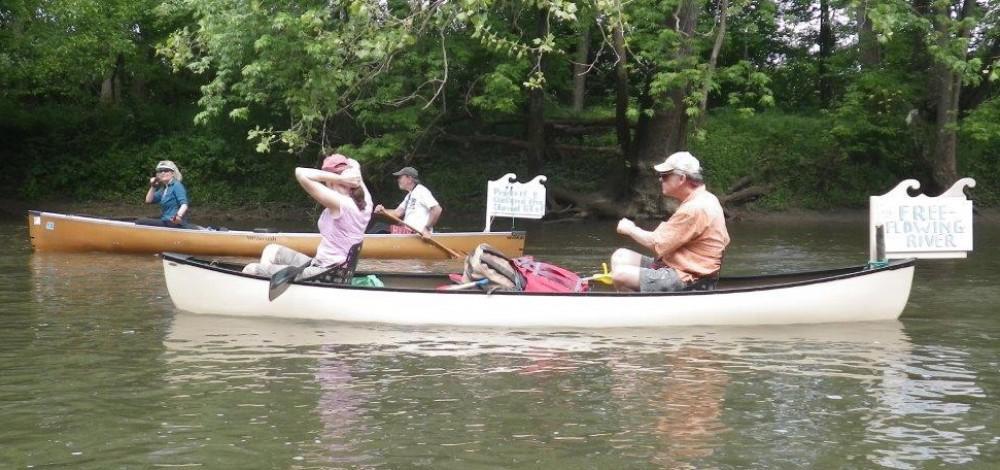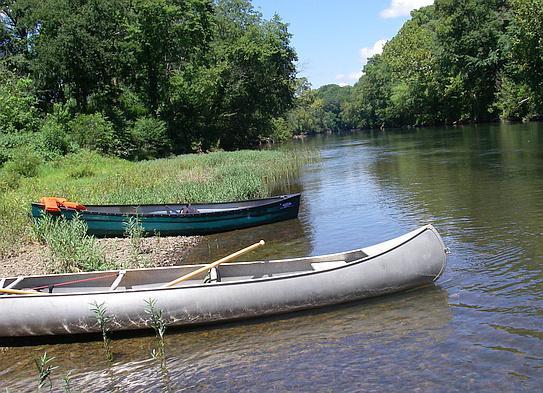The first image is the image on the left, the second image is the image on the right. Considering the images on both sides, is "An image includes a canoe with multiple riders afloat on the water." valid? Answer yes or no. Yes. The first image is the image on the left, the second image is the image on the right. Assess this claim about the two images: "At least one person is standing on the shore in the image on the right.". Correct or not? Answer yes or no. No. 